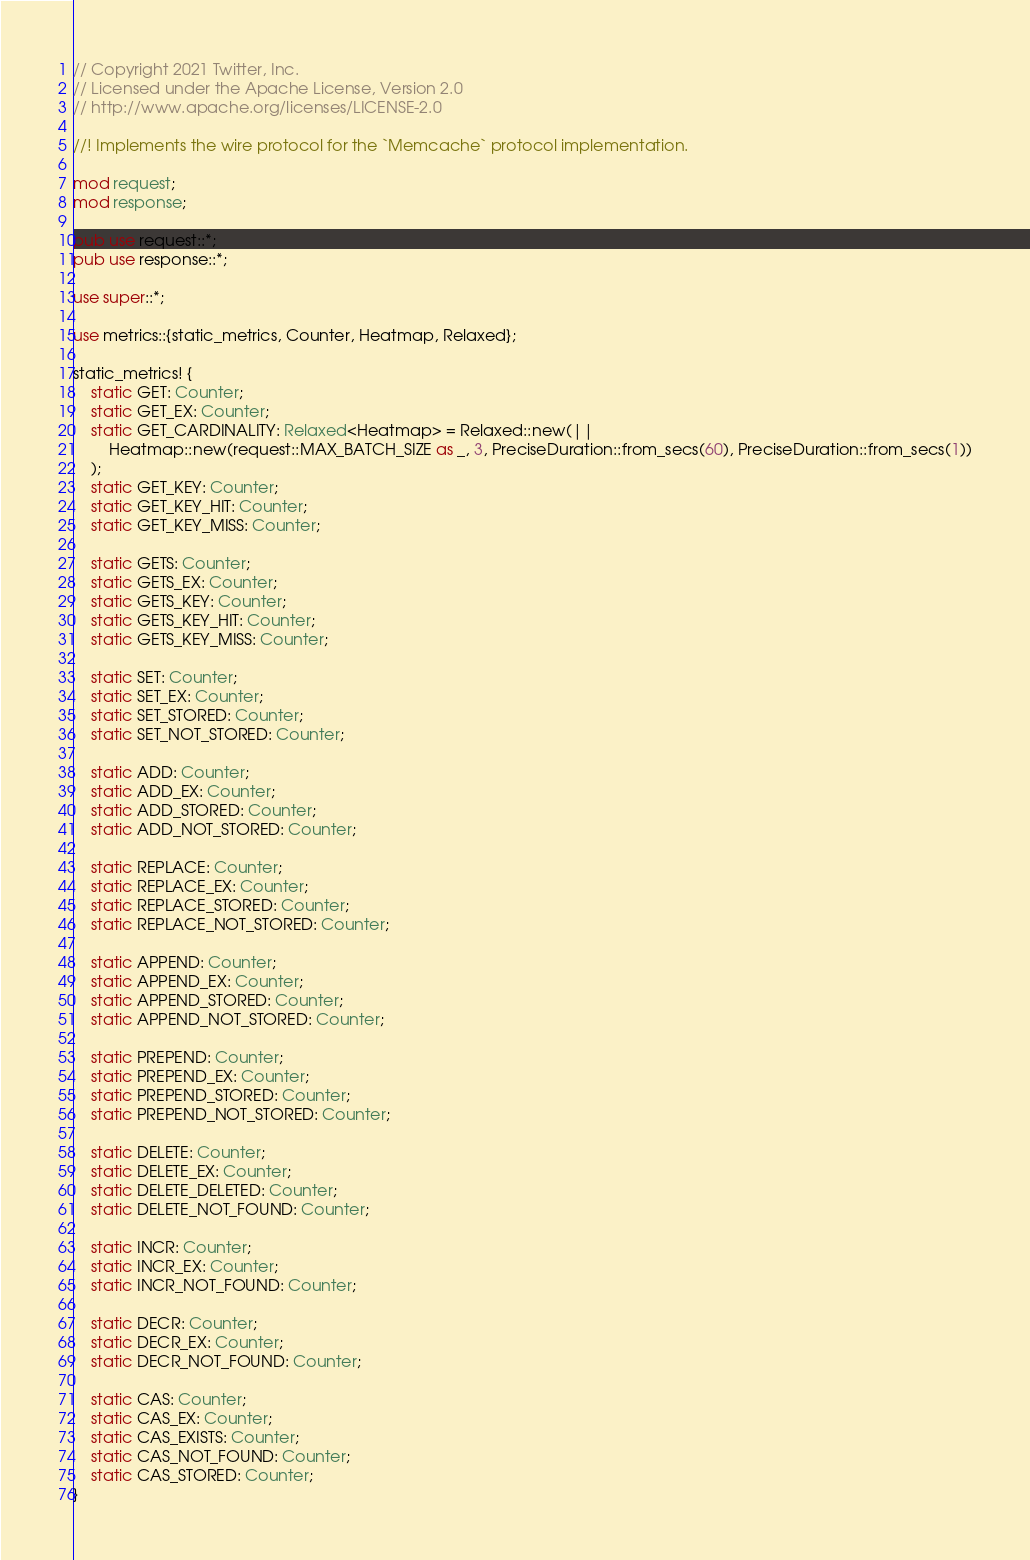<code> <loc_0><loc_0><loc_500><loc_500><_Rust_>// Copyright 2021 Twitter, Inc.
// Licensed under the Apache License, Version 2.0
// http://www.apache.org/licenses/LICENSE-2.0

//! Implements the wire protocol for the `Memcache` protocol implementation.

mod request;
mod response;

pub use request::*;
pub use response::*;

use super::*;

use metrics::{static_metrics, Counter, Heatmap, Relaxed};

static_metrics! {
    static GET: Counter;
    static GET_EX: Counter;
    static GET_CARDINALITY: Relaxed<Heatmap> = Relaxed::new(||
        Heatmap::new(request::MAX_BATCH_SIZE as _, 3, PreciseDuration::from_secs(60), PreciseDuration::from_secs(1))
    );
    static GET_KEY: Counter;
    static GET_KEY_HIT: Counter;
    static GET_KEY_MISS: Counter;

    static GETS: Counter;
    static GETS_EX: Counter;
    static GETS_KEY: Counter;
    static GETS_KEY_HIT: Counter;
    static GETS_KEY_MISS: Counter;

    static SET: Counter;
    static SET_EX: Counter;
    static SET_STORED: Counter;
    static SET_NOT_STORED: Counter;

    static ADD: Counter;
    static ADD_EX: Counter;
    static ADD_STORED: Counter;
    static ADD_NOT_STORED: Counter;

    static REPLACE: Counter;
    static REPLACE_EX: Counter;
    static REPLACE_STORED: Counter;
    static REPLACE_NOT_STORED: Counter;

    static APPEND: Counter;
    static APPEND_EX: Counter;
    static APPEND_STORED: Counter;
    static APPEND_NOT_STORED: Counter;

    static PREPEND: Counter;
    static PREPEND_EX: Counter;
    static PREPEND_STORED: Counter;
    static PREPEND_NOT_STORED: Counter;

    static DELETE: Counter;
    static DELETE_EX: Counter;
    static DELETE_DELETED: Counter;
    static DELETE_NOT_FOUND: Counter;

    static INCR: Counter;
    static INCR_EX: Counter;
    static INCR_NOT_FOUND: Counter;

    static DECR: Counter;
    static DECR_EX: Counter;
    static DECR_NOT_FOUND: Counter;

    static CAS: Counter;
    static CAS_EX: Counter;
    static CAS_EXISTS: Counter;
    static CAS_NOT_FOUND: Counter;
    static CAS_STORED: Counter;
}
</code> 